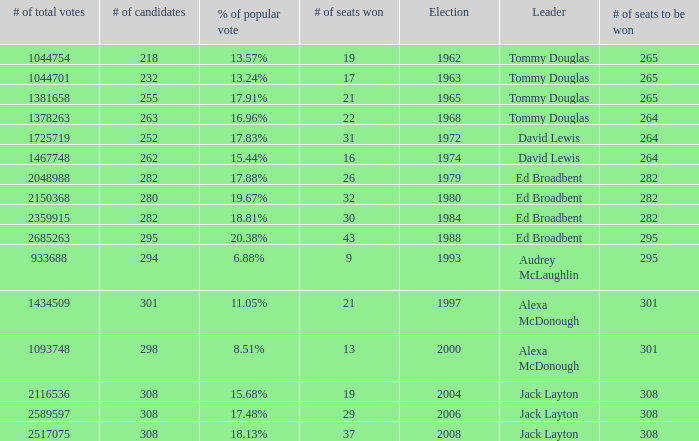Name the number of total votes for # of seats won being 30 2359915.0. 